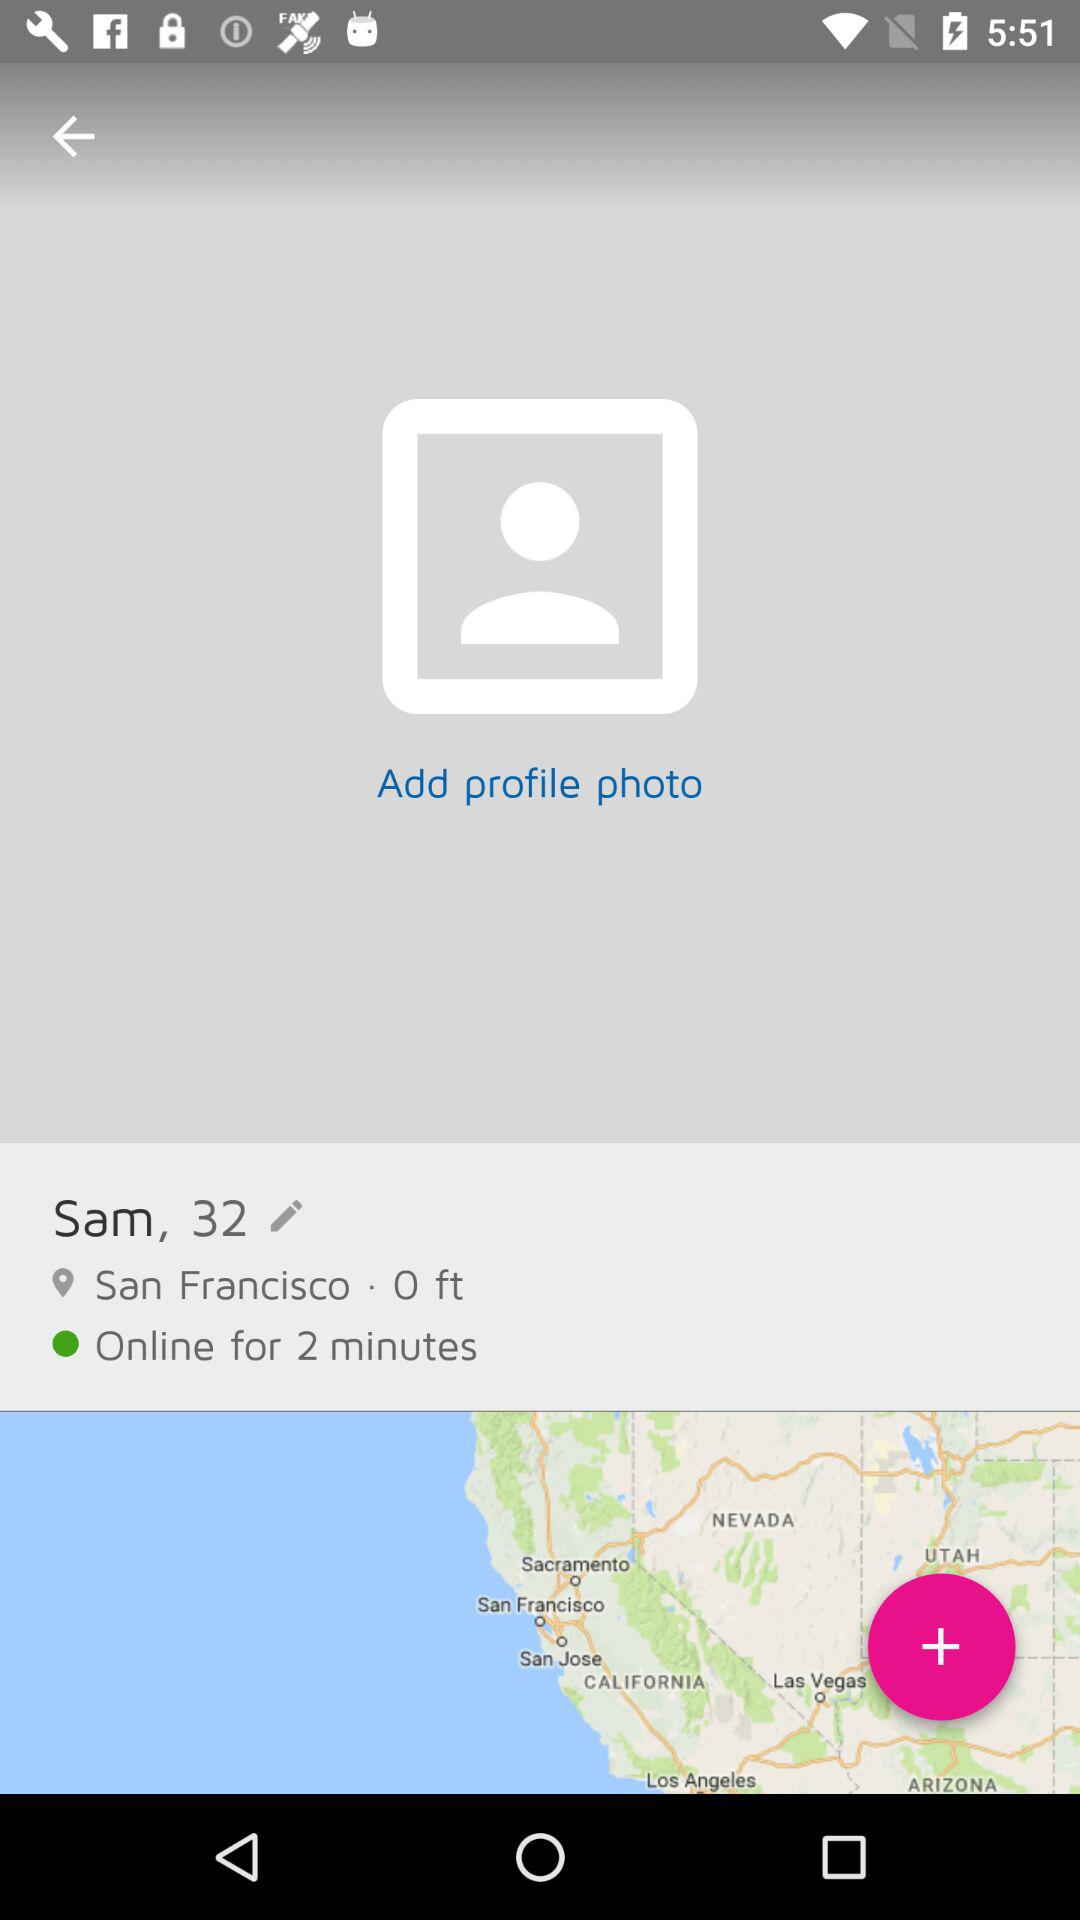For how much time duration has the user been online? The user has been online for 2 minutes. 